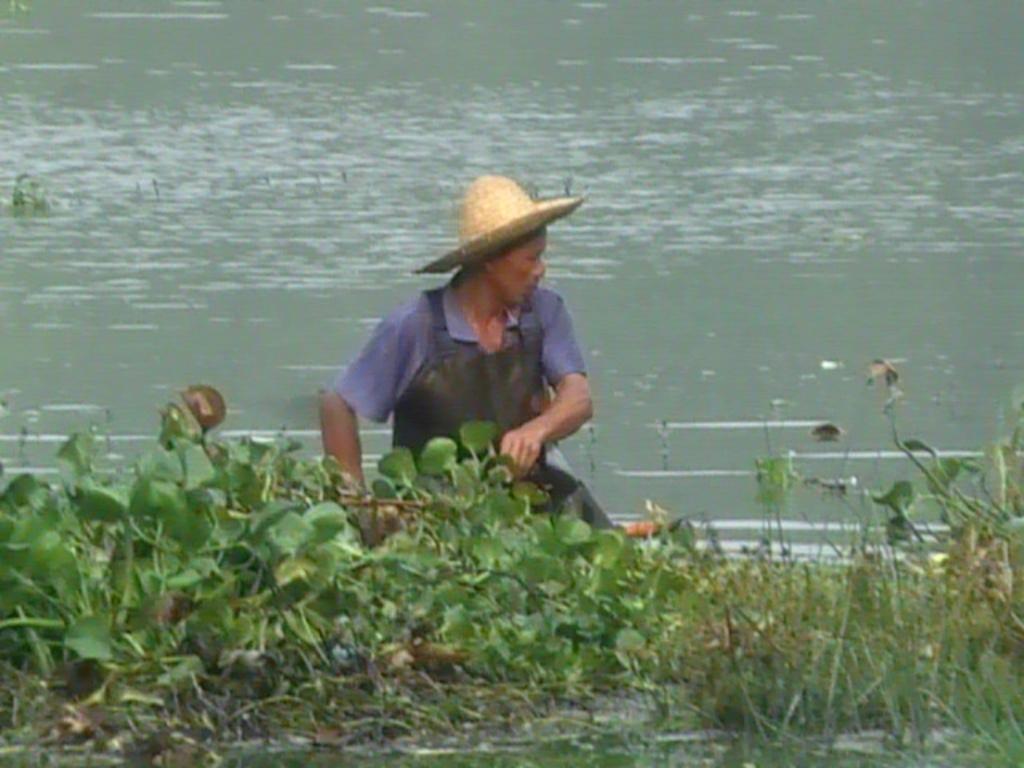Please provide a concise description of this image. In this image we can see a person, there are few plants in front of the person and water in the background. 